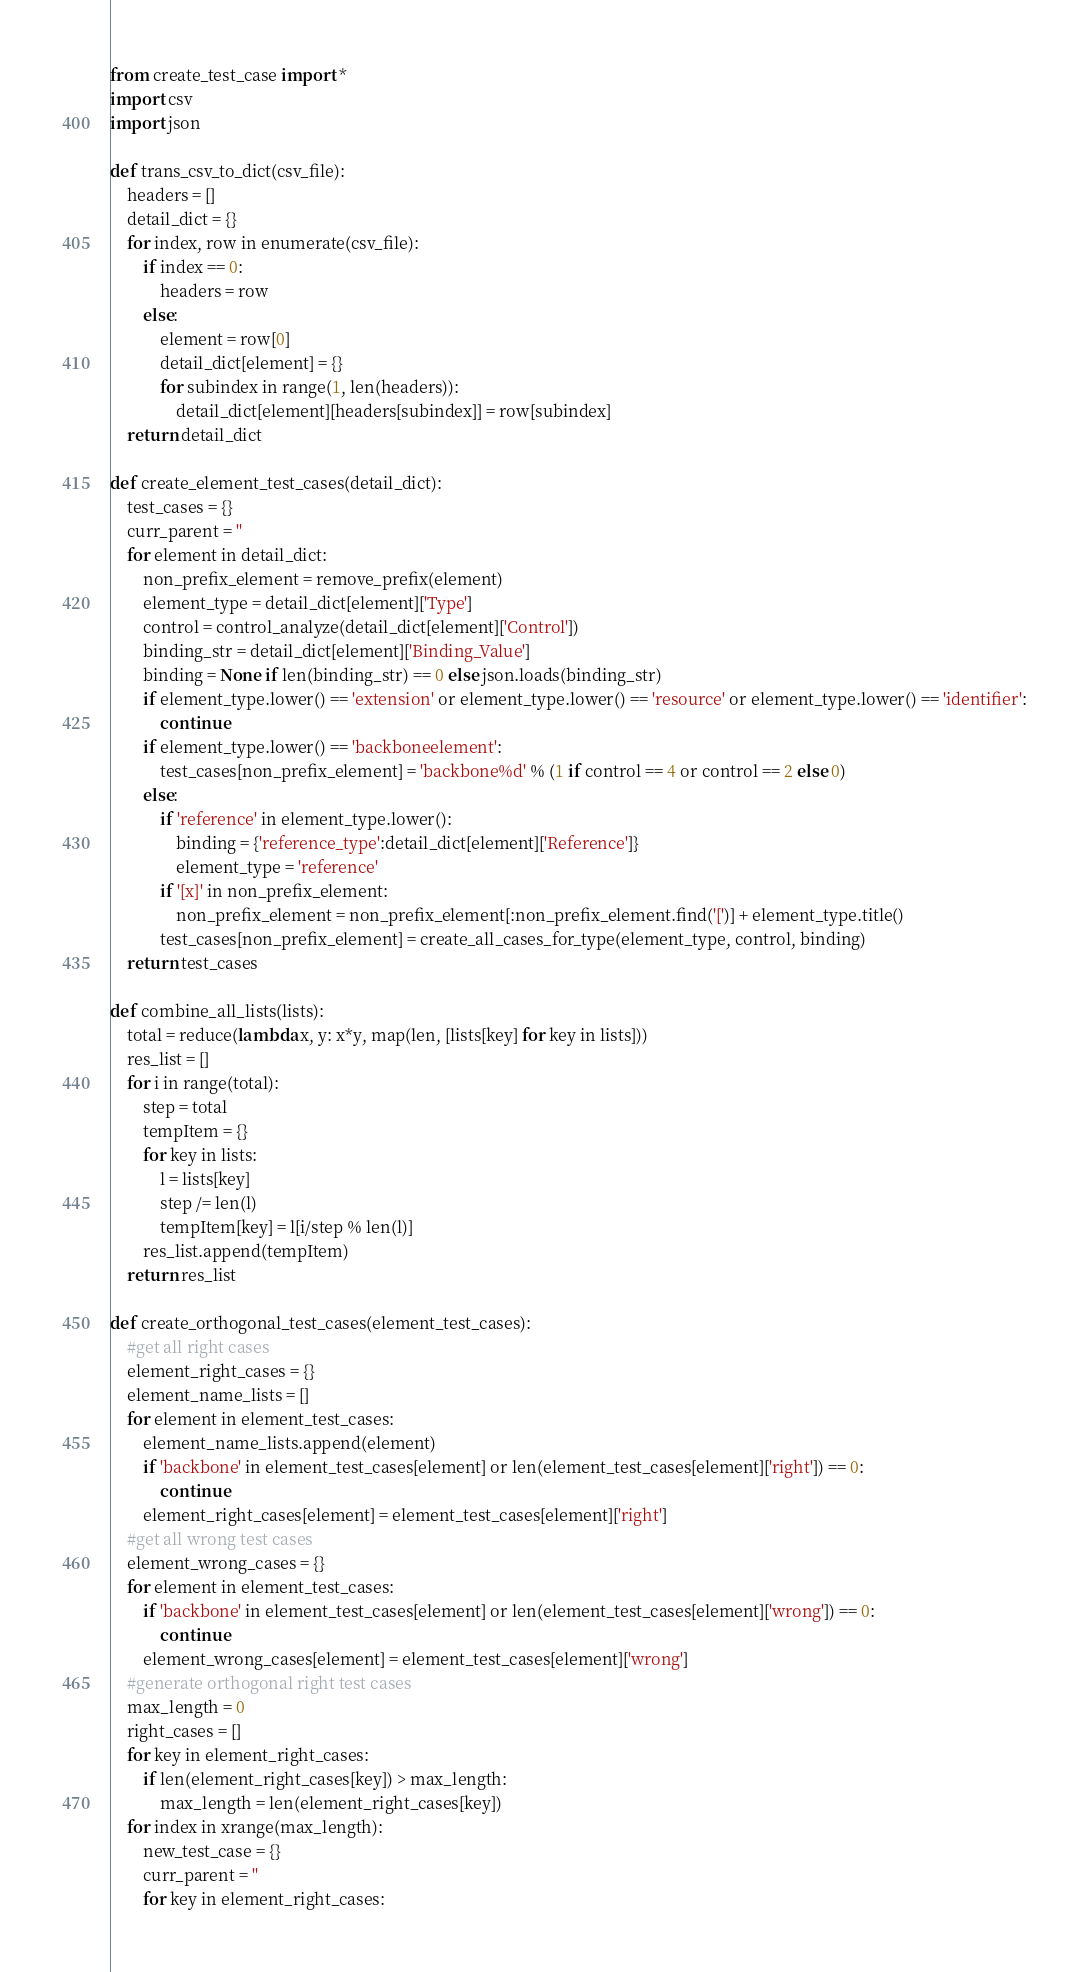<code> <loc_0><loc_0><loc_500><loc_500><_Python_>from create_test_case import *
import csv
import json

def trans_csv_to_dict(csv_file):
    headers = []
    detail_dict = {}
    for index, row in enumerate(csv_file):
        if index == 0:
            headers = row
        else:
            element = row[0]
            detail_dict[element] = {}
            for subindex in range(1, len(headers)):
                detail_dict[element][headers[subindex]] = row[subindex]
    return detail_dict

def create_element_test_cases(detail_dict):
    test_cases = {}
    curr_parent = ''
    for element in detail_dict:
        non_prefix_element = remove_prefix(element)
        element_type = detail_dict[element]['Type']
        control = control_analyze(detail_dict[element]['Control'])
        binding_str = detail_dict[element]['Binding_Value']
        binding = None if len(binding_str) == 0 else json.loads(binding_str)
        if element_type.lower() == 'extension' or element_type.lower() == 'resource' or element_type.lower() == 'identifier':
            continue
        if element_type.lower() == 'backboneelement':
            test_cases[non_prefix_element] = 'backbone%d' % (1 if control == 4 or control == 2 else 0)
        else:
            if 'reference' in element_type.lower():
                binding = {'reference_type':detail_dict[element]['Reference']}
                element_type = 'reference'
            if '[x]' in non_prefix_element:
                non_prefix_element = non_prefix_element[:non_prefix_element.find('[')] + element_type.title()
            test_cases[non_prefix_element] = create_all_cases_for_type(element_type, control, binding)
    return test_cases

def combine_all_lists(lists):
    total = reduce(lambda x, y: x*y, map(len, [lists[key] for key in lists]))
    res_list = []
    for i in range(total):
        step = total
        tempItem = {}
        for key in lists:
            l = lists[key]
            step /= len(l)
            tempItem[key] = l[i/step % len(l)]
        res_list.append(tempItem)
    return res_list

def create_orthogonal_test_cases(element_test_cases):
    #get all right cases
    element_right_cases = {}
    element_name_lists = []
    for element in element_test_cases:
        element_name_lists.append(element)
        if 'backbone' in element_test_cases[element] or len(element_test_cases[element]['right']) == 0:
            continue
        element_right_cases[element] = element_test_cases[element]['right']
    #get all wrong test cases
    element_wrong_cases = {}
    for element in element_test_cases:
        if 'backbone' in element_test_cases[element] or len(element_test_cases[element]['wrong']) == 0:
            continue
        element_wrong_cases[element] = element_test_cases[element]['wrong']
    #generate orthogonal right test cases
    max_length = 0
    right_cases = []
    for key in element_right_cases:
        if len(element_right_cases[key]) > max_length:
            max_length = len(element_right_cases[key])
    for index in xrange(max_length):
        new_test_case = {}
        curr_parent = ''
        for key in element_right_cases:</code> 